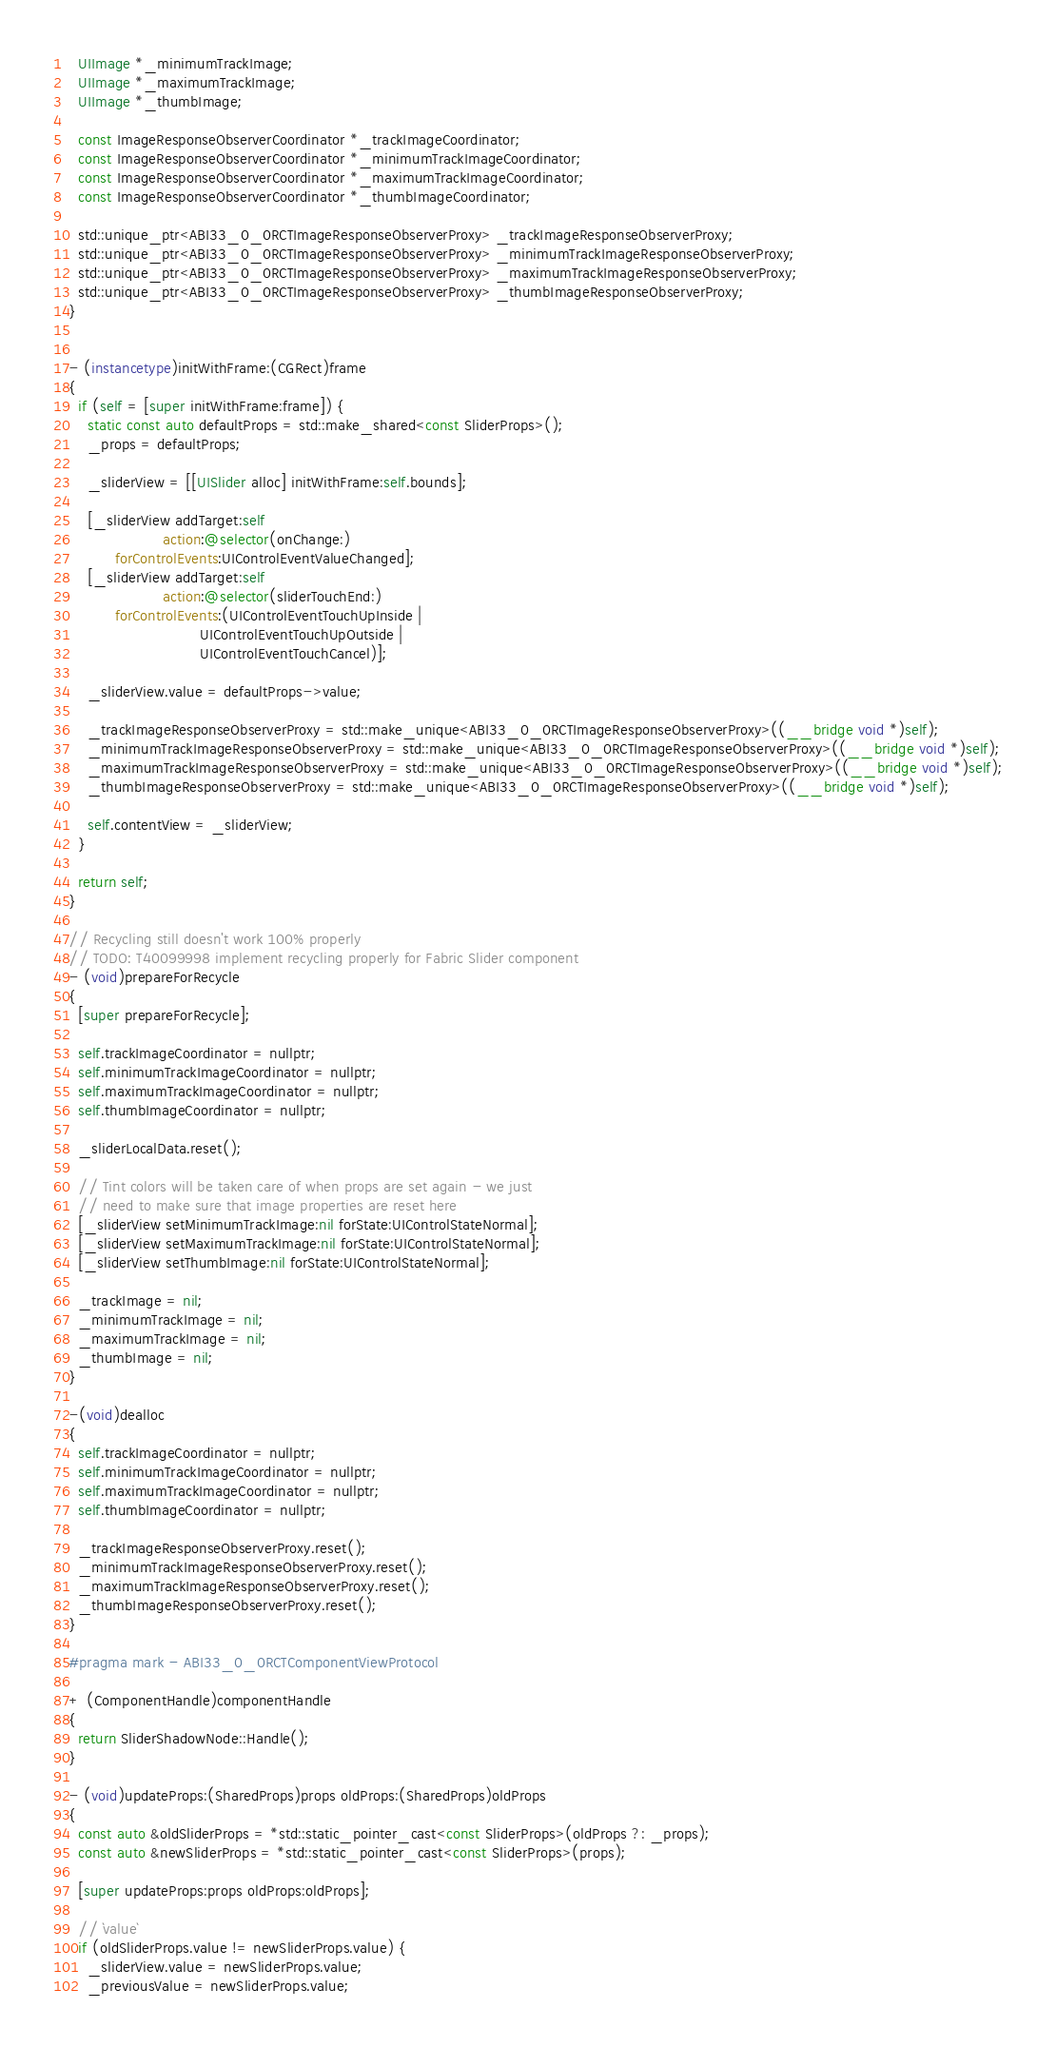<code> <loc_0><loc_0><loc_500><loc_500><_ObjectiveC_>  UIImage *_minimumTrackImage;
  UIImage *_maximumTrackImage;
  UIImage *_thumbImage;
  
  const ImageResponseObserverCoordinator *_trackImageCoordinator;
  const ImageResponseObserverCoordinator *_minimumTrackImageCoordinator;
  const ImageResponseObserverCoordinator *_maximumTrackImageCoordinator;
  const ImageResponseObserverCoordinator *_thumbImageCoordinator;

  std::unique_ptr<ABI33_0_0RCTImageResponseObserverProxy> _trackImageResponseObserverProxy;
  std::unique_ptr<ABI33_0_0RCTImageResponseObserverProxy> _minimumTrackImageResponseObserverProxy;
  std::unique_ptr<ABI33_0_0RCTImageResponseObserverProxy> _maximumTrackImageResponseObserverProxy;
  std::unique_ptr<ABI33_0_0RCTImageResponseObserverProxy> _thumbImageResponseObserverProxy;
}


- (instancetype)initWithFrame:(CGRect)frame
{
  if (self = [super initWithFrame:frame]) {
    static const auto defaultProps = std::make_shared<const SliderProps>();
    _props = defaultProps;

    _sliderView = [[UISlider alloc] initWithFrame:self.bounds];

    [_sliderView addTarget:self
                    action:@selector(onChange:)
          forControlEvents:UIControlEventValueChanged];
    [_sliderView addTarget:self
                    action:@selector(sliderTouchEnd:)
          forControlEvents:(UIControlEventTouchUpInside |
                            UIControlEventTouchUpOutside |
                            UIControlEventTouchCancel)];

    _sliderView.value = defaultProps->value;

    _trackImageResponseObserverProxy = std::make_unique<ABI33_0_0RCTImageResponseObserverProxy>((__bridge void *)self);
    _minimumTrackImageResponseObserverProxy = std::make_unique<ABI33_0_0RCTImageResponseObserverProxy>((__bridge void *)self);
    _maximumTrackImageResponseObserverProxy = std::make_unique<ABI33_0_0RCTImageResponseObserverProxy>((__bridge void *)self);
    _thumbImageResponseObserverProxy = std::make_unique<ABI33_0_0RCTImageResponseObserverProxy>((__bridge void *)self);

    self.contentView = _sliderView;
  }

  return self;
}

// Recycling still doesn't work 100% properly
// TODO: T40099998 implement recycling properly for Fabric Slider component
- (void)prepareForRecycle
{
  [super prepareForRecycle];
  
  self.trackImageCoordinator = nullptr;
  self.minimumTrackImageCoordinator = nullptr;
  self.maximumTrackImageCoordinator = nullptr;
  self.thumbImageCoordinator = nullptr;

  _sliderLocalData.reset();

  // Tint colors will be taken care of when props are set again - we just
  // need to make sure that image properties are reset here
  [_sliderView setMinimumTrackImage:nil forState:UIControlStateNormal];
  [_sliderView setMaximumTrackImage:nil forState:UIControlStateNormal];
  [_sliderView setThumbImage:nil forState:UIControlStateNormal];

  _trackImage = nil;
  _minimumTrackImage = nil;
  _maximumTrackImage = nil;
  _thumbImage = nil;
}

-(void)dealloc
{
  self.trackImageCoordinator = nullptr;
  self.minimumTrackImageCoordinator = nullptr;
  self.maximumTrackImageCoordinator = nullptr;
  self.thumbImageCoordinator = nullptr;

  _trackImageResponseObserverProxy.reset();
  _minimumTrackImageResponseObserverProxy.reset();
  _maximumTrackImageResponseObserverProxy.reset();
  _thumbImageResponseObserverProxy.reset();
}

#pragma mark - ABI33_0_0RCTComponentViewProtocol

+ (ComponentHandle)componentHandle
{
  return SliderShadowNode::Handle();
}

- (void)updateProps:(SharedProps)props oldProps:(SharedProps)oldProps
{
  const auto &oldSliderProps = *std::static_pointer_cast<const SliderProps>(oldProps ?: _props);
  const auto &newSliderProps = *std::static_pointer_cast<const SliderProps>(props);

  [super updateProps:props oldProps:oldProps];

  // `value`
  if (oldSliderProps.value != newSliderProps.value) {
    _sliderView.value = newSliderProps.value;
    _previousValue = newSliderProps.value;</code> 